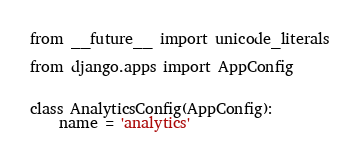Convert code to text. <code><loc_0><loc_0><loc_500><loc_500><_Python_>from __future__ import unicode_literals

from django.apps import AppConfig


class AnalyticsConfig(AppConfig):
    name = 'analytics'
</code> 